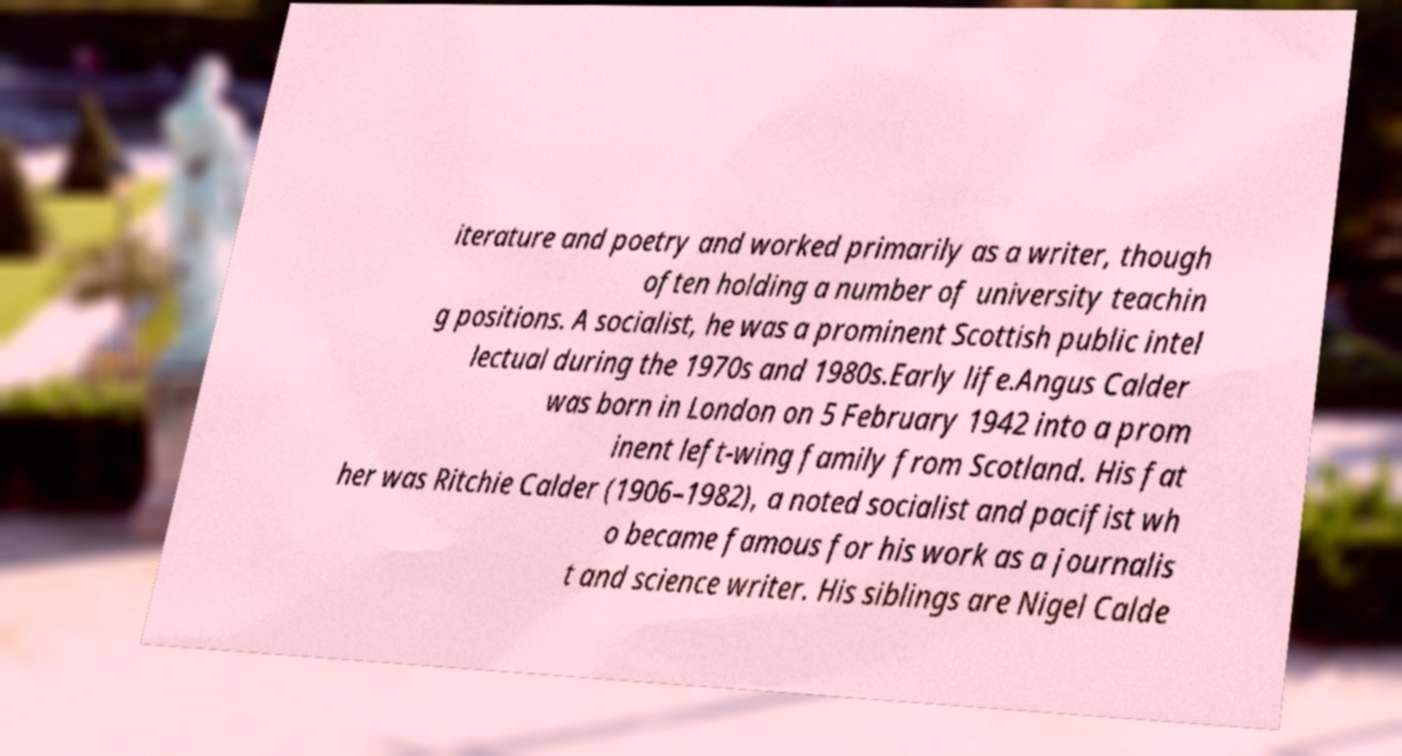Can you read and provide the text displayed in the image?This photo seems to have some interesting text. Can you extract and type it out for me? iterature and poetry and worked primarily as a writer, though often holding a number of university teachin g positions. A socialist, he was a prominent Scottish public intel lectual during the 1970s and 1980s.Early life.Angus Calder was born in London on 5 February 1942 into a prom inent left-wing family from Scotland. His fat her was Ritchie Calder (1906–1982), a noted socialist and pacifist wh o became famous for his work as a journalis t and science writer. His siblings are Nigel Calde 